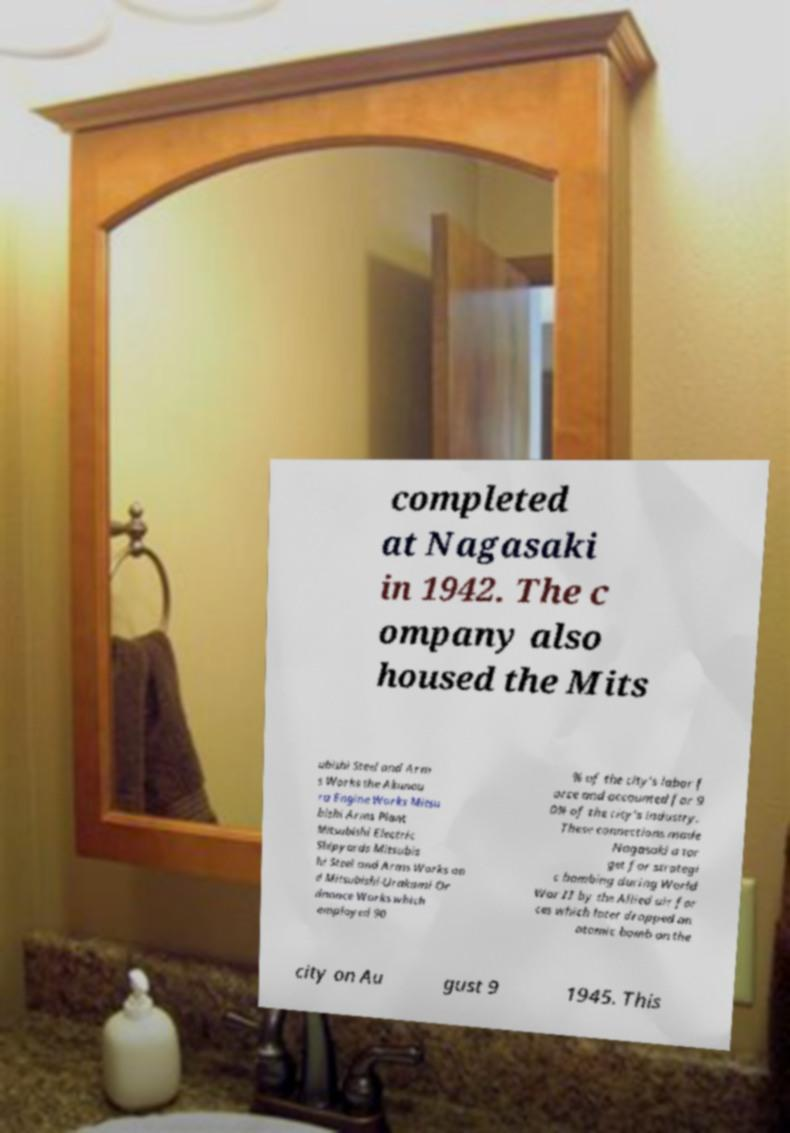Please identify and transcribe the text found in this image. completed at Nagasaki in 1942. The c ompany also housed the Mits ubishi Steel and Arm s Works the Akunou ra Engine Works Mitsu bishi Arms Plant Mitsubishi Electric Shipyards Mitsubis hi Steel and Arms Works an d Mitsubishi-Urakami Or dnance Works which employed 90 % of the city's labor f orce and accounted for 9 0% of the city's industry. These connections made Nagasaki a tar get for strategi c bombing during World War II by the Allied air for ces which later dropped an atomic bomb on the city on Au gust 9 1945. This 